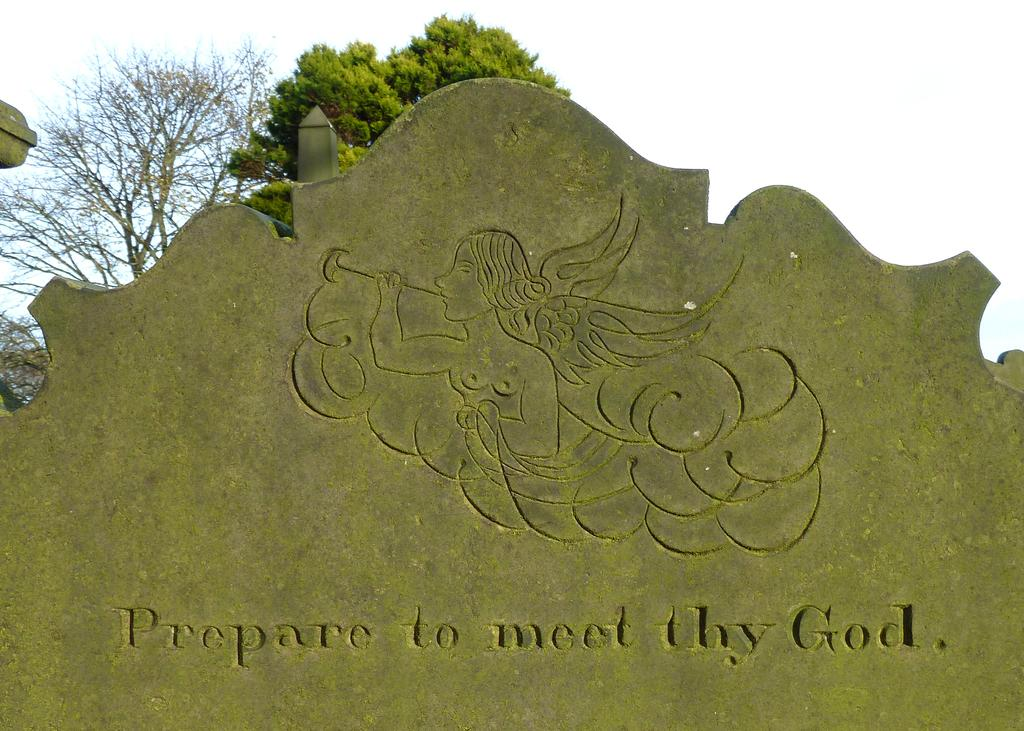What type of decorations can be seen on the wall in the image? There are carvings on the wall in the image. What type of vegetation is visible in the image? There are trees visible in the image. What can be seen in the background of the image? The sky is visible in the background of the image. Can you hear the bushes crying in the image? There are no bushes or crying sounds present in the image. Is the image set during the night? The provided facts do not mention the time of day, so it cannot be determined if the image is set during the night. 